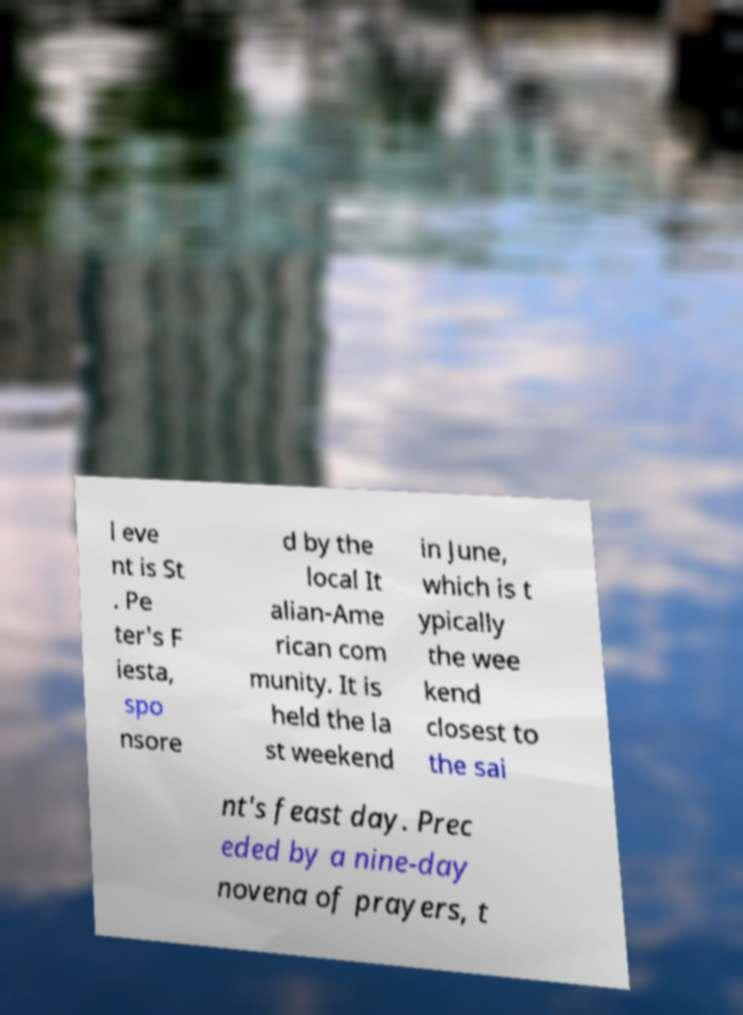Could you assist in decoding the text presented in this image and type it out clearly? l eve nt is St . Pe ter's F iesta, spo nsore d by the local It alian-Ame rican com munity. It is held the la st weekend in June, which is t ypically the wee kend closest to the sai nt's feast day. Prec eded by a nine-day novena of prayers, t 